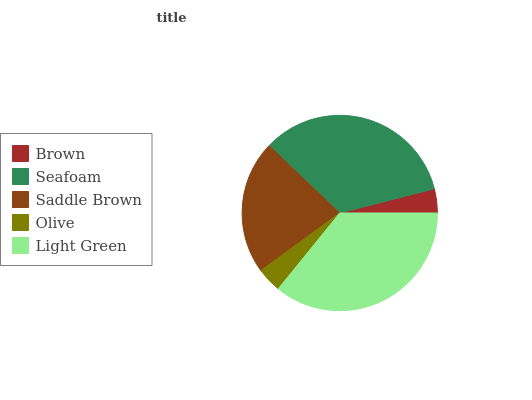Is Brown the minimum?
Answer yes or no. Yes. Is Light Green the maximum?
Answer yes or no. Yes. Is Seafoam the minimum?
Answer yes or no. No. Is Seafoam the maximum?
Answer yes or no. No. Is Seafoam greater than Brown?
Answer yes or no. Yes. Is Brown less than Seafoam?
Answer yes or no. Yes. Is Brown greater than Seafoam?
Answer yes or no. No. Is Seafoam less than Brown?
Answer yes or no. No. Is Saddle Brown the high median?
Answer yes or no. Yes. Is Saddle Brown the low median?
Answer yes or no. Yes. Is Olive the high median?
Answer yes or no. No. Is Light Green the low median?
Answer yes or no. No. 